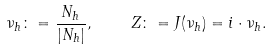Convert formula to latex. <formula><loc_0><loc_0><loc_500><loc_500>\nu _ { h } \colon = \frac { N _ { h } } { | N _ { h } | } , \quad Z \colon = J ( \nu _ { h } ) = i \cdot \nu _ { h } .</formula> 